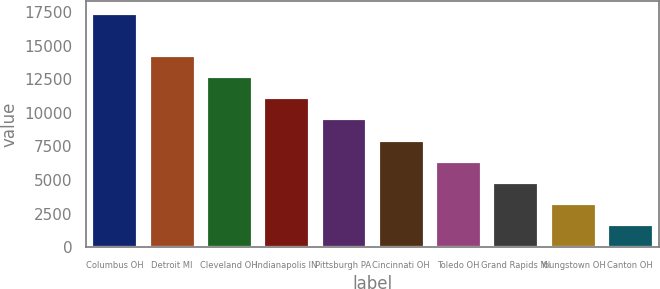Convert chart. <chart><loc_0><loc_0><loc_500><loc_500><bar_chart><fcel>Columbus OH<fcel>Detroit MI<fcel>Cleveland OH<fcel>Indianapolis IN<fcel>Pittsburgh PA<fcel>Cincinnati OH<fcel>Toledo OH<fcel>Grand Rapids MI<fcel>Youngstown OH<fcel>Canton OH<nl><fcel>17450<fcel>14301.6<fcel>12727.4<fcel>11153.2<fcel>9579<fcel>8004.8<fcel>6430.6<fcel>4856.4<fcel>3282.2<fcel>1708<nl></chart> 